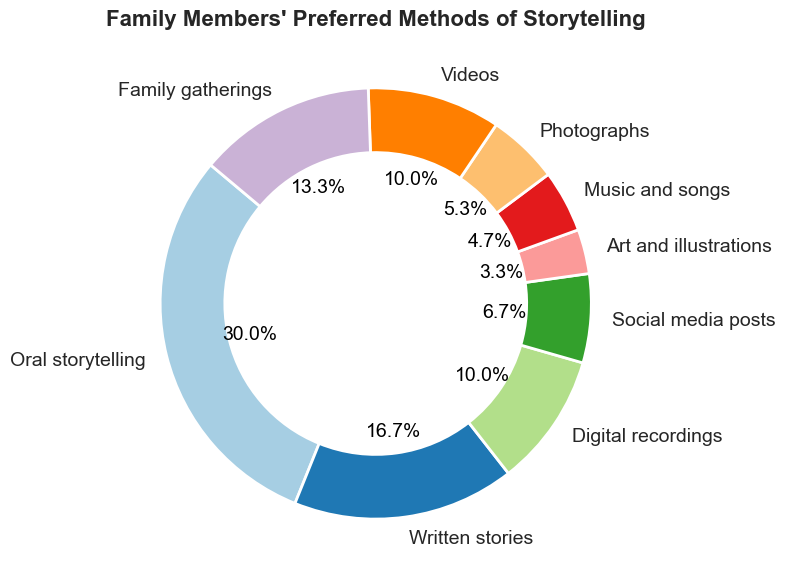What percentage of family members prefer oral storytelling? To find the percentage, look at the segment labeled "Oral storytelling". The figure shows "45", which corresponds to a percentage displayed next to the segment.
Answer: 45% How many family members prefer videos over photographs? First, identify the number of family members for both methods. "Videos" and "Photographs" segments show 15 and 8 respectively. Subtract the latter from the former. 15 - 8 = 7
Answer: 7 Which storytelling method is least preferred by family members? Look at the pie chart and find the segment with the smallest count. The smallest percentage should correspond to the method "Art and illustrations" which has 5 family members.
Answer: Art and illustrations What's the combined percentage of family members who prefer written stories and digital recordings? Identify the segments for "Written stories" and "Digital recordings". Their counts are 25 and 15 respectively. The percentages are displayed next to the segments. 25% + 15% = 40%
Answer: 40% Compare the number of family members who prefer social media posts and music/songs. Which one is more popular and by how much? Find the counts for "Social media posts" (10) and "Music and songs" (7). Subtract the smaller number from the larger one. 10 - 7 = 3.
Answer: Social media posts, by 3 What is the approximate percentage of family members who prefer family gatherings? Locate the "Family gatherings" segment, which shows a count of 20. The percentage displayed on the chart next to the segment would be approximately 20%.
Answer: 20% If you combine the preferences for music and photographs, do they surpass the count for digital recordings or not? Add the counts for "Music and songs" (7) and "Photographs" (8). Compare the sum (7 + 8 = 15) with the count for "Digital recordings" (15). They are equal.
Answer: No, they are equal Which method has the highest count, and what is the numerical difference between this and the second most popular method? "Oral storytelling" has the highest count (45). "Written stories" is the second most popular (25). Subtract the latter from the former. 45 - 25 = 20.
Answer: Oral storytelling, 20 What fraction of the family prefers using art and illustrations for storytelling? Locate the segment for "Art and illustrations" which has 5 members. There are a total of 160 members; hence, the fraction is 5/160. Simplify the fraction. 5/160 = 1/32.
Answer: 1/32 